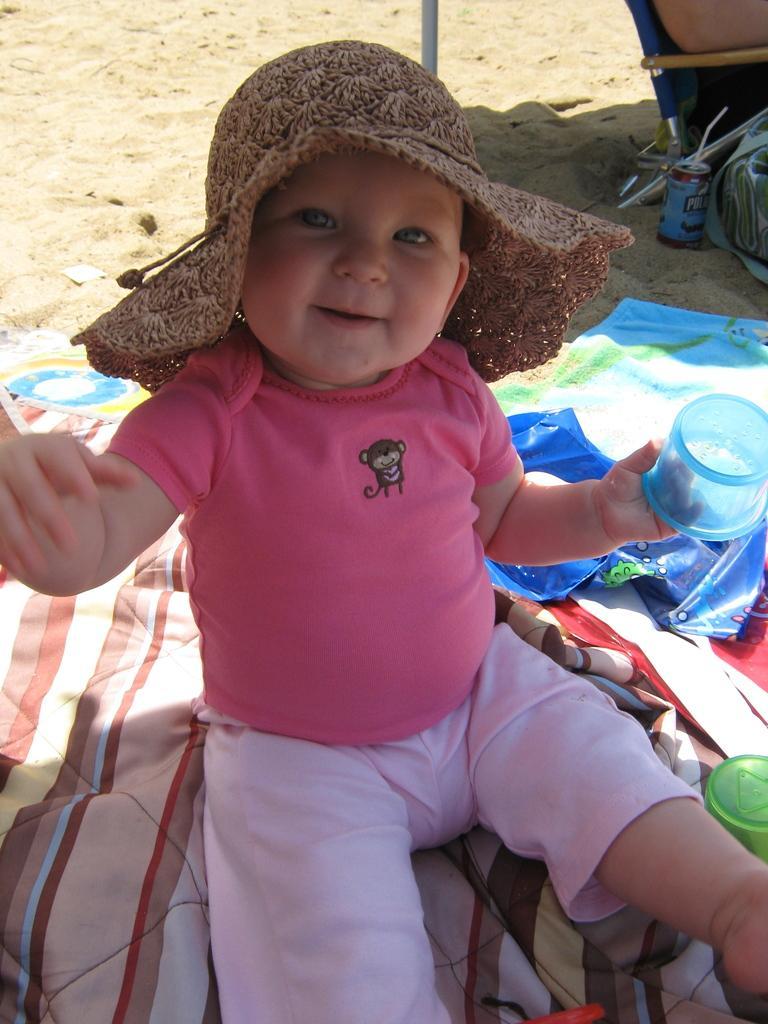Can you describe this image briefly? In this image I can see a boy is sitting on a cloth. I can see he is holding a blue colour thing. I can also see he is wearing pink colour dress and a brown colour hat. On the right side of this image I can see a green colour thing and in the background can see a can, shadows and few other stuffs. 